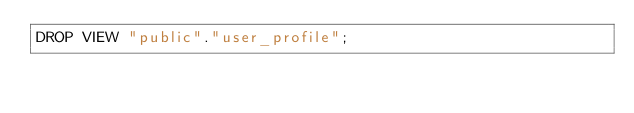Convert code to text. <code><loc_0><loc_0><loc_500><loc_500><_SQL_>DROP VIEW "public"."user_profile";
</code> 